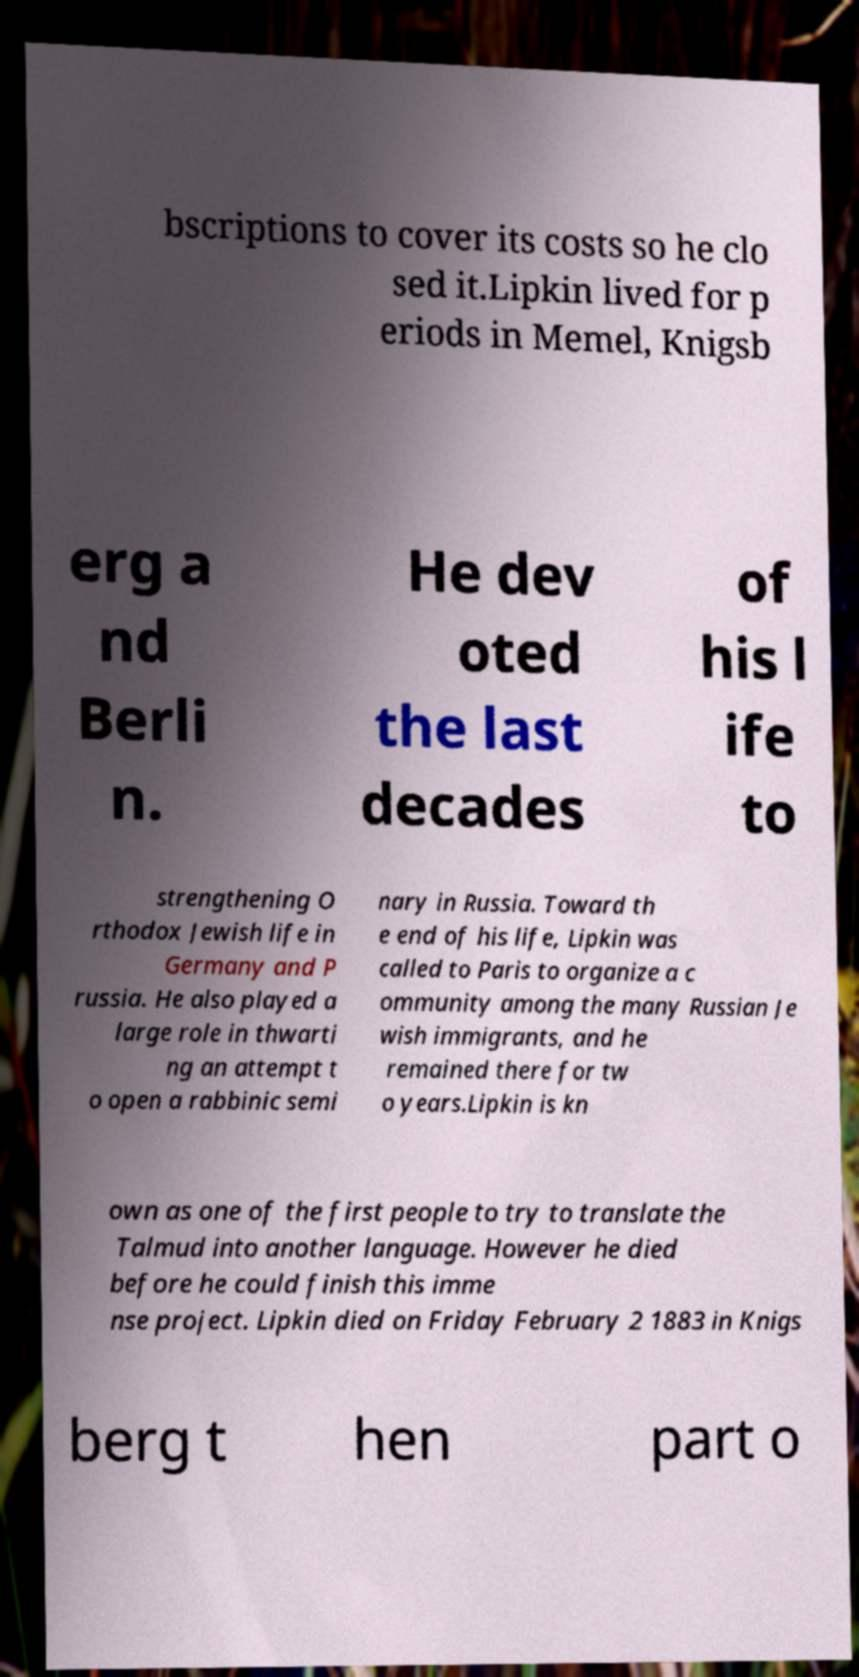For documentation purposes, I need the text within this image transcribed. Could you provide that? bscriptions to cover its costs so he clo sed it.Lipkin lived for p eriods in Memel, Knigsb erg a nd Berli n. He dev oted the last decades of his l ife to strengthening O rthodox Jewish life in Germany and P russia. He also played a large role in thwarti ng an attempt t o open a rabbinic semi nary in Russia. Toward th e end of his life, Lipkin was called to Paris to organize a c ommunity among the many Russian Je wish immigrants, and he remained there for tw o years.Lipkin is kn own as one of the first people to try to translate the Talmud into another language. However he died before he could finish this imme nse project. Lipkin died on Friday February 2 1883 in Knigs berg t hen part o 